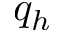Convert formula to latex. <formula><loc_0><loc_0><loc_500><loc_500>q _ { h }</formula> 